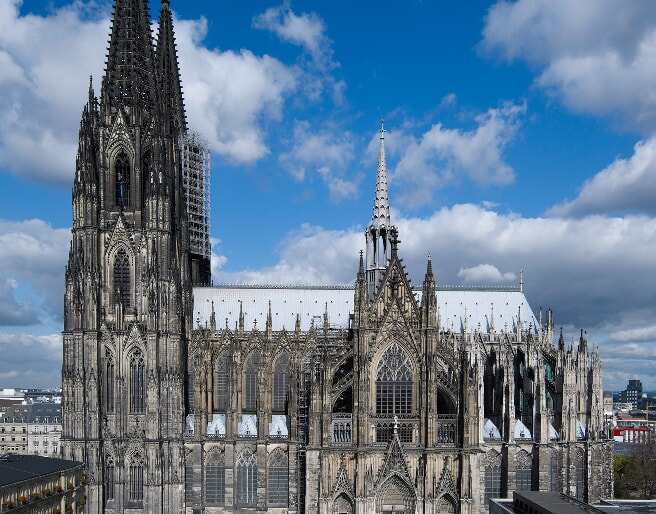What is the historical significance of Cologne Cathedral? Cologne Cathedral, or Kölner Dom, is significant not only for its architectural grandeur but also for its history. Construction began in 1248, aimed at housing the relics of the Three Kings, and despite interruptions, it was completed to original plans in 1880. Over the ages, it has served as a beacon of faith and resilience, surviving extensive bombing during World War II virtually intact amidst an otherwise devastated Cologne. The cathedral was declared a World Heritage Site in 1996, symbolizing its immense cultural and historical import. 